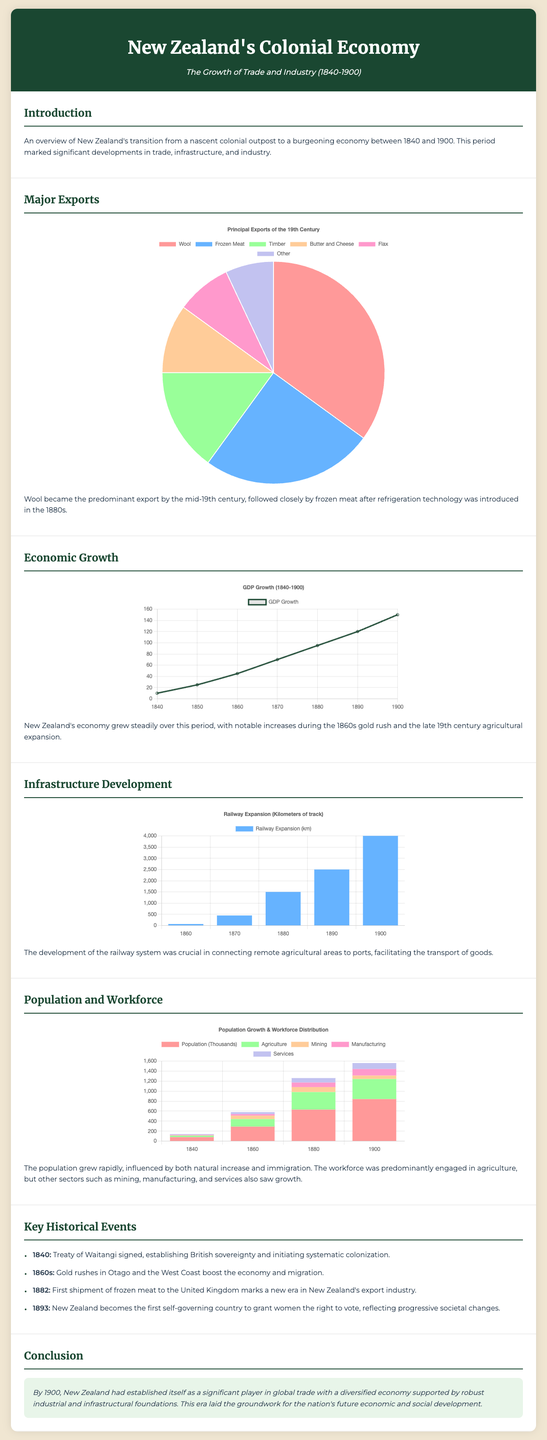What was New Zealand's predominant export by the mid-19th century? The document states that wool became the predominant export.
Answer: Wool What year did the first shipment of frozen meat occur? According to the timeline in the document, the first shipment of frozen meat to the UK was in 1882.
Answer: 1882 How many kilometers of railway were there by 1900? The railway chart mentions that there were 4000 kilometers of railway in 1900.
Answer: 4000 What was the population of New Zealand in 1860? The population chart indicates that the population was 290,000 in 1860.
Answer: 290 Which sector had the largest workforce in 1880? The population chart indicates that agriculture had the largest workforce with 350,000 people in 1880.
Answer: Agriculture During what decade did the gold rushes significantly boost the economy? The document mentions that the gold rushes occurred in the 1860s.
Answer: 1860s What percentage of exports was represented by frozen meat? According to the pie chart, frozen meat constituted 25% of the exports.
Answer: 25% What was the GDP in 1900 according to the growth chart? The GDP chart shows that the GDP reached 150 in 1900.
Answer: 150 